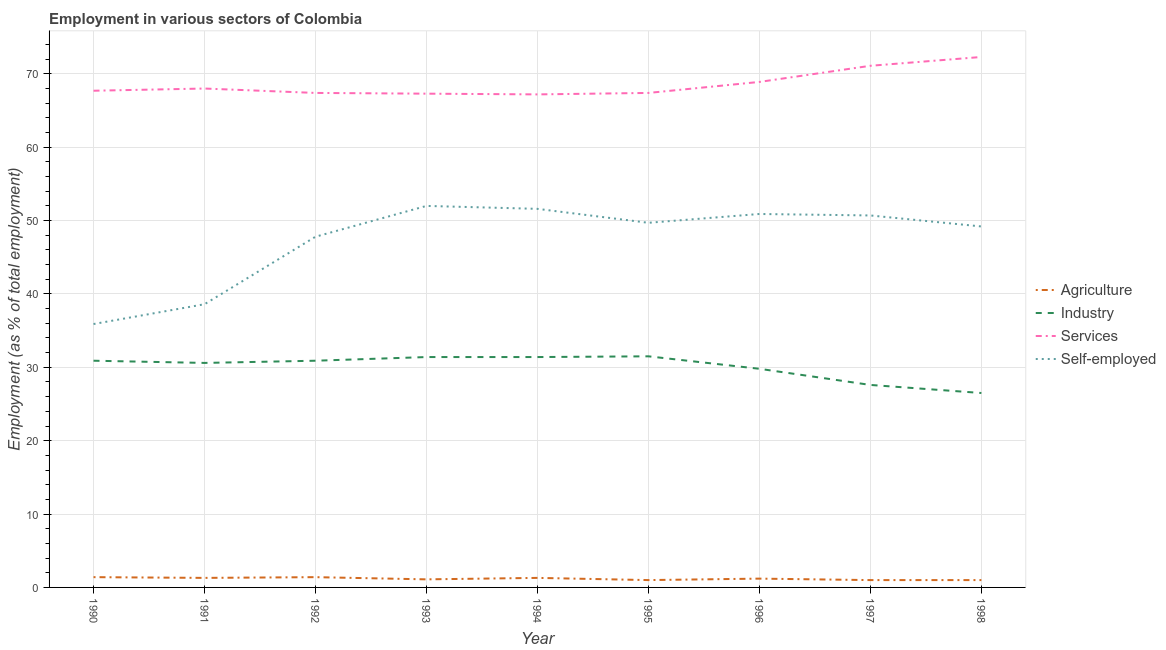How many different coloured lines are there?
Make the answer very short. 4. Does the line corresponding to percentage of workers in services intersect with the line corresponding to percentage of self employed workers?
Give a very brief answer. No. Is the number of lines equal to the number of legend labels?
Your answer should be very brief. Yes. What is the percentage of workers in industry in 1990?
Offer a very short reply. 30.9. Across all years, what is the maximum percentage of self employed workers?
Keep it short and to the point. 52. Across all years, what is the minimum percentage of workers in services?
Your response must be concise. 67.2. In which year was the percentage of workers in services maximum?
Your answer should be very brief. 1998. What is the total percentage of self employed workers in the graph?
Make the answer very short. 426.4. What is the difference between the percentage of workers in industry in 1992 and that in 1998?
Your response must be concise. 4.4. What is the difference between the percentage of workers in services in 1993 and the percentage of self employed workers in 1996?
Provide a short and direct response. 16.4. What is the average percentage of self employed workers per year?
Ensure brevity in your answer.  47.38. In the year 1993, what is the difference between the percentage of workers in services and percentage of workers in industry?
Your answer should be compact. 35.9. What is the ratio of the percentage of workers in agriculture in 1990 to that in 1995?
Your answer should be compact. 1.4. Is the difference between the percentage of workers in agriculture in 1990 and 1997 greater than the difference between the percentage of self employed workers in 1990 and 1997?
Provide a short and direct response. Yes. What is the difference between the highest and the second highest percentage of workers in services?
Your answer should be very brief. 1.2. What is the difference between the highest and the lowest percentage of workers in services?
Provide a succinct answer. 5.1. Is the percentage of self employed workers strictly greater than the percentage of workers in agriculture over the years?
Give a very brief answer. Yes. Is the percentage of workers in services strictly less than the percentage of self employed workers over the years?
Offer a very short reply. No. How many lines are there?
Your answer should be compact. 4. What is the difference between two consecutive major ticks on the Y-axis?
Provide a short and direct response. 10. Are the values on the major ticks of Y-axis written in scientific E-notation?
Your answer should be very brief. No. How are the legend labels stacked?
Provide a succinct answer. Vertical. What is the title of the graph?
Your answer should be compact. Employment in various sectors of Colombia. What is the label or title of the Y-axis?
Give a very brief answer. Employment (as % of total employment). What is the Employment (as % of total employment) in Agriculture in 1990?
Keep it short and to the point. 1.4. What is the Employment (as % of total employment) in Industry in 1990?
Provide a succinct answer. 30.9. What is the Employment (as % of total employment) in Services in 1990?
Make the answer very short. 67.7. What is the Employment (as % of total employment) in Self-employed in 1990?
Your answer should be very brief. 35.9. What is the Employment (as % of total employment) in Agriculture in 1991?
Your answer should be very brief. 1.3. What is the Employment (as % of total employment) in Industry in 1991?
Provide a short and direct response. 30.6. What is the Employment (as % of total employment) of Self-employed in 1991?
Your answer should be compact. 38.6. What is the Employment (as % of total employment) in Agriculture in 1992?
Give a very brief answer. 1.4. What is the Employment (as % of total employment) of Industry in 1992?
Provide a short and direct response. 30.9. What is the Employment (as % of total employment) of Services in 1992?
Offer a terse response. 67.4. What is the Employment (as % of total employment) in Self-employed in 1992?
Provide a succinct answer. 47.8. What is the Employment (as % of total employment) in Agriculture in 1993?
Keep it short and to the point. 1.1. What is the Employment (as % of total employment) in Industry in 1993?
Your response must be concise. 31.4. What is the Employment (as % of total employment) in Services in 1993?
Your answer should be compact. 67.3. What is the Employment (as % of total employment) of Agriculture in 1994?
Make the answer very short. 1.3. What is the Employment (as % of total employment) of Industry in 1994?
Give a very brief answer. 31.4. What is the Employment (as % of total employment) of Services in 1994?
Give a very brief answer. 67.2. What is the Employment (as % of total employment) in Self-employed in 1994?
Your answer should be very brief. 51.6. What is the Employment (as % of total employment) in Industry in 1995?
Your answer should be very brief. 31.5. What is the Employment (as % of total employment) of Services in 1995?
Offer a very short reply. 67.4. What is the Employment (as % of total employment) in Self-employed in 1995?
Your response must be concise. 49.7. What is the Employment (as % of total employment) of Agriculture in 1996?
Your answer should be compact. 1.2. What is the Employment (as % of total employment) in Industry in 1996?
Give a very brief answer. 29.8. What is the Employment (as % of total employment) of Services in 1996?
Ensure brevity in your answer.  68.9. What is the Employment (as % of total employment) in Self-employed in 1996?
Your answer should be compact. 50.9. What is the Employment (as % of total employment) of Industry in 1997?
Provide a succinct answer. 27.6. What is the Employment (as % of total employment) in Services in 1997?
Offer a terse response. 71.1. What is the Employment (as % of total employment) of Self-employed in 1997?
Your response must be concise. 50.7. What is the Employment (as % of total employment) in Industry in 1998?
Keep it short and to the point. 26.5. What is the Employment (as % of total employment) of Services in 1998?
Make the answer very short. 72.3. What is the Employment (as % of total employment) in Self-employed in 1998?
Offer a very short reply. 49.2. Across all years, what is the maximum Employment (as % of total employment) of Agriculture?
Make the answer very short. 1.4. Across all years, what is the maximum Employment (as % of total employment) in Industry?
Your answer should be compact. 31.5. Across all years, what is the maximum Employment (as % of total employment) of Services?
Ensure brevity in your answer.  72.3. Across all years, what is the maximum Employment (as % of total employment) in Self-employed?
Offer a very short reply. 52. Across all years, what is the minimum Employment (as % of total employment) of Agriculture?
Keep it short and to the point. 1. Across all years, what is the minimum Employment (as % of total employment) of Services?
Your answer should be very brief. 67.2. Across all years, what is the minimum Employment (as % of total employment) in Self-employed?
Your answer should be very brief. 35.9. What is the total Employment (as % of total employment) of Agriculture in the graph?
Keep it short and to the point. 10.7. What is the total Employment (as % of total employment) of Industry in the graph?
Your response must be concise. 270.6. What is the total Employment (as % of total employment) of Services in the graph?
Your answer should be compact. 617.3. What is the total Employment (as % of total employment) of Self-employed in the graph?
Make the answer very short. 426.4. What is the difference between the Employment (as % of total employment) of Agriculture in 1990 and that in 1991?
Keep it short and to the point. 0.1. What is the difference between the Employment (as % of total employment) of Services in 1990 and that in 1991?
Give a very brief answer. -0.3. What is the difference between the Employment (as % of total employment) in Services in 1990 and that in 1992?
Your answer should be very brief. 0.3. What is the difference between the Employment (as % of total employment) in Self-employed in 1990 and that in 1993?
Keep it short and to the point. -16.1. What is the difference between the Employment (as % of total employment) in Agriculture in 1990 and that in 1994?
Give a very brief answer. 0.1. What is the difference between the Employment (as % of total employment) in Industry in 1990 and that in 1994?
Provide a short and direct response. -0.5. What is the difference between the Employment (as % of total employment) of Services in 1990 and that in 1994?
Offer a very short reply. 0.5. What is the difference between the Employment (as % of total employment) of Self-employed in 1990 and that in 1994?
Keep it short and to the point. -15.7. What is the difference between the Employment (as % of total employment) of Agriculture in 1990 and that in 1995?
Offer a very short reply. 0.4. What is the difference between the Employment (as % of total employment) in Self-employed in 1990 and that in 1995?
Your answer should be compact. -13.8. What is the difference between the Employment (as % of total employment) in Services in 1990 and that in 1996?
Provide a succinct answer. -1.2. What is the difference between the Employment (as % of total employment) of Agriculture in 1990 and that in 1997?
Offer a terse response. 0.4. What is the difference between the Employment (as % of total employment) of Industry in 1990 and that in 1997?
Your answer should be compact. 3.3. What is the difference between the Employment (as % of total employment) of Self-employed in 1990 and that in 1997?
Your response must be concise. -14.8. What is the difference between the Employment (as % of total employment) of Agriculture in 1990 and that in 1998?
Your answer should be very brief. 0.4. What is the difference between the Employment (as % of total employment) in Industry in 1990 and that in 1998?
Keep it short and to the point. 4.4. What is the difference between the Employment (as % of total employment) in Services in 1990 and that in 1998?
Your answer should be very brief. -4.6. What is the difference between the Employment (as % of total employment) of Self-employed in 1991 and that in 1992?
Keep it short and to the point. -9.2. What is the difference between the Employment (as % of total employment) of Agriculture in 1991 and that in 1993?
Offer a terse response. 0.2. What is the difference between the Employment (as % of total employment) in Industry in 1991 and that in 1993?
Your answer should be very brief. -0.8. What is the difference between the Employment (as % of total employment) of Services in 1991 and that in 1993?
Provide a short and direct response. 0.7. What is the difference between the Employment (as % of total employment) in Self-employed in 1991 and that in 1993?
Your response must be concise. -13.4. What is the difference between the Employment (as % of total employment) in Industry in 1991 and that in 1994?
Keep it short and to the point. -0.8. What is the difference between the Employment (as % of total employment) in Services in 1991 and that in 1994?
Provide a short and direct response. 0.8. What is the difference between the Employment (as % of total employment) of Self-employed in 1991 and that in 1994?
Your answer should be compact. -13. What is the difference between the Employment (as % of total employment) of Agriculture in 1991 and that in 1995?
Provide a succinct answer. 0.3. What is the difference between the Employment (as % of total employment) of Services in 1991 and that in 1996?
Your answer should be compact. -0.9. What is the difference between the Employment (as % of total employment) in Industry in 1991 and that in 1997?
Keep it short and to the point. 3. What is the difference between the Employment (as % of total employment) of Services in 1991 and that in 1997?
Give a very brief answer. -3.1. What is the difference between the Employment (as % of total employment) in Agriculture in 1991 and that in 1998?
Ensure brevity in your answer.  0.3. What is the difference between the Employment (as % of total employment) in Agriculture in 1992 and that in 1993?
Provide a succinct answer. 0.3. What is the difference between the Employment (as % of total employment) of Industry in 1992 and that in 1993?
Offer a terse response. -0.5. What is the difference between the Employment (as % of total employment) of Self-employed in 1992 and that in 1993?
Make the answer very short. -4.2. What is the difference between the Employment (as % of total employment) in Industry in 1992 and that in 1994?
Provide a short and direct response. -0.5. What is the difference between the Employment (as % of total employment) in Services in 1992 and that in 1994?
Keep it short and to the point. 0.2. What is the difference between the Employment (as % of total employment) of Self-employed in 1992 and that in 1994?
Provide a succinct answer. -3.8. What is the difference between the Employment (as % of total employment) of Agriculture in 1992 and that in 1995?
Your answer should be very brief. 0.4. What is the difference between the Employment (as % of total employment) of Services in 1992 and that in 1995?
Keep it short and to the point. 0. What is the difference between the Employment (as % of total employment) of Agriculture in 1992 and that in 1996?
Keep it short and to the point. 0.2. What is the difference between the Employment (as % of total employment) of Industry in 1992 and that in 1997?
Give a very brief answer. 3.3. What is the difference between the Employment (as % of total employment) of Self-employed in 1992 and that in 1997?
Provide a succinct answer. -2.9. What is the difference between the Employment (as % of total employment) of Industry in 1992 and that in 1998?
Your answer should be compact. 4.4. What is the difference between the Employment (as % of total employment) in Industry in 1993 and that in 1994?
Your answer should be compact. 0. What is the difference between the Employment (as % of total employment) in Services in 1993 and that in 1994?
Provide a short and direct response. 0.1. What is the difference between the Employment (as % of total employment) of Self-employed in 1993 and that in 1994?
Offer a terse response. 0.4. What is the difference between the Employment (as % of total employment) of Agriculture in 1993 and that in 1995?
Give a very brief answer. 0.1. What is the difference between the Employment (as % of total employment) in Services in 1993 and that in 1995?
Your answer should be very brief. -0.1. What is the difference between the Employment (as % of total employment) in Self-employed in 1993 and that in 1995?
Ensure brevity in your answer.  2.3. What is the difference between the Employment (as % of total employment) in Industry in 1993 and that in 1997?
Your answer should be compact. 3.8. What is the difference between the Employment (as % of total employment) of Self-employed in 1993 and that in 1997?
Provide a short and direct response. 1.3. What is the difference between the Employment (as % of total employment) of Agriculture in 1993 and that in 1998?
Your answer should be very brief. 0.1. What is the difference between the Employment (as % of total employment) in Services in 1993 and that in 1998?
Provide a succinct answer. -5. What is the difference between the Employment (as % of total employment) in Industry in 1994 and that in 1995?
Provide a short and direct response. -0.1. What is the difference between the Employment (as % of total employment) of Self-employed in 1994 and that in 1995?
Your response must be concise. 1.9. What is the difference between the Employment (as % of total employment) of Services in 1994 and that in 1996?
Your response must be concise. -1.7. What is the difference between the Employment (as % of total employment) of Self-employed in 1994 and that in 1996?
Your response must be concise. 0.7. What is the difference between the Employment (as % of total employment) of Services in 1994 and that in 1997?
Provide a short and direct response. -3.9. What is the difference between the Employment (as % of total employment) of Industry in 1994 and that in 1998?
Your answer should be compact. 4.9. What is the difference between the Employment (as % of total employment) in Self-employed in 1994 and that in 1998?
Provide a succinct answer. 2.4. What is the difference between the Employment (as % of total employment) in Agriculture in 1995 and that in 1996?
Your response must be concise. -0.2. What is the difference between the Employment (as % of total employment) in Industry in 1995 and that in 1996?
Your answer should be compact. 1.7. What is the difference between the Employment (as % of total employment) in Self-employed in 1995 and that in 1996?
Give a very brief answer. -1.2. What is the difference between the Employment (as % of total employment) of Industry in 1995 and that in 1997?
Offer a very short reply. 3.9. What is the difference between the Employment (as % of total employment) in Services in 1995 and that in 1997?
Provide a succinct answer. -3.7. What is the difference between the Employment (as % of total employment) in Agriculture in 1995 and that in 1998?
Provide a short and direct response. 0. What is the difference between the Employment (as % of total employment) in Industry in 1995 and that in 1998?
Make the answer very short. 5. What is the difference between the Employment (as % of total employment) of Agriculture in 1996 and that in 1997?
Make the answer very short. 0.2. What is the difference between the Employment (as % of total employment) in Industry in 1996 and that in 1997?
Ensure brevity in your answer.  2.2. What is the difference between the Employment (as % of total employment) in Self-employed in 1996 and that in 1997?
Make the answer very short. 0.2. What is the difference between the Employment (as % of total employment) in Agriculture in 1996 and that in 1998?
Your answer should be very brief. 0.2. What is the difference between the Employment (as % of total employment) of Services in 1996 and that in 1998?
Your answer should be very brief. -3.4. What is the difference between the Employment (as % of total employment) in Agriculture in 1997 and that in 1998?
Offer a very short reply. 0. What is the difference between the Employment (as % of total employment) of Self-employed in 1997 and that in 1998?
Your answer should be compact. 1.5. What is the difference between the Employment (as % of total employment) in Agriculture in 1990 and the Employment (as % of total employment) in Industry in 1991?
Provide a succinct answer. -29.2. What is the difference between the Employment (as % of total employment) in Agriculture in 1990 and the Employment (as % of total employment) in Services in 1991?
Your response must be concise. -66.6. What is the difference between the Employment (as % of total employment) in Agriculture in 1990 and the Employment (as % of total employment) in Self-employed in 1991?
Ensure brevity in your answer.  -37.2. What is the difference between the Employment (as % of total employment) in Industry in 1990 and the Employment (as % of total employment) in Services in 1991?
Make the answer very short. -37.1. What is the difference between the Employment (as % of total employment) of Industry in 1990 and the Employment (as % of total employment) of Self-employed in 1991?
Your answer should be very brief. -7.7. What is the difference between the Employment (as % of total employment) of Services in 1990 and the Employment (as % of total employment) of Self-employed in 1991?
Your answer should be compact. 29.1. What is the difference between the Employment (as % of total employment) of Agriculture in 1990 and the Employment (as % of total employment) of Industry in 1992?
Provide a succinct answer. -29.5. What is the difference between the Employment (as % of total employment) in Agriculture in 1990 and the Employment (as % of total employment) in Services in 1992?
Your response must be concise. -66. What is the difference between the Employment (as % of total employment) of Agriculture in 1990 and the Employment (as % of total employment) of Self-employed in 1992?
Your answer should be very brief. -46.4. What is the difference between the Employment (as % of total employment) of Industry in 1990 and the Employment (as % of total employment) of Services in 1992?
Give a very brief answer. -36.5. What is the difference between the Employment (as % of total employment) of Industry in 1990 and the Employment (as % of total employment) of Self-employed in 1992?
Offer a terse response. -16.9. What is the difference between the Employment (as % of total employment) of Agriculture in 1990 and the Employment (as % of total employment) of Industry in 1993?
Provide a succinct answer. -30. What is the difference between the Employment (as % of total employment) in Agriculture in 1990 and the Employment (as % of total employment) in Services in 1993?
Offer a very short reply. -65.9. What is the difference between the Employment (as % of total employment) of Agriculture in 1990 and the Employment (as % of total employment) of Self-employed in 1993?
Give a very brief answer. -50.6. What is the difference between the Employment (as % of total employment) of Industry in 1990 and the Employment (as % of total employment) of Services in 1993?
Offer a very short reply. -36.4. What is the difference between the Employment (as % of total employment) of Industry in 1990 and the Employment (as % of total employment) of Self-employed in 1993?
Ensure brevity in your answer.  -21.1. What is the difference between the Employment (as % of total employment) in Services in 1990 and the Employment (as % of total employment) in Self-employed in 1993?
Your response must be concise. 15.7. What is the difference between the Employment (as % of total employment) in Agriculture in 1990 and the Employment (as % of total employment) in Industry in 1994?
Provide a short and direct response. -30. What is the difference between the Employment (as % of total employment) of Agriculture in 1990 and the Employment (as % of total employment) of Services in 1994?
Provide a short and direct response. -65.8. What is the difference between the Employment (as % of total employment) in Agriculture in 1990 and the Employment (as % of total employment) in Self-employed in 1994?
Your answer should be very brief. -50.2. What is the difference between the Employment (as % of total employment) of Industry in 1990 and the Employment (as % of total employment) of Services in 1994?
Your answer should be compact. -36.3. What is the difference between the Employment (as % of total employment) in Industry in 1990 and the Employment (as % of total employment) in Self-employed in 1994?
Keep it short and to the point. -20.7. What is the difference between the Employment (as % of total employment) of Services in 1990 and the Employment (as % of total employment) of Self-employed in 1994?
Provide a succinct answer. 16.1. What is the difference between the Employment (as % of total employment) in Agriculture in 1990 and the Employment (as % of total employment) in Industry in 1995?
Keep it short and to the point. -30.1. What is the difference between the Employment (as % of total employment) in Agriculture in 1990 and the Employment (as % of total employment) in Services in 1995?
Ensure brevity in your answer.  -66. What is the difference between the Employment (as % of total employment) in Agriculture in 1990 and the Employment (as % of total employment) in Self-employed in 1995?
Offer a terse response. -48.3. What is the difference between the Employment (as % of total employment) in Industry in 1990 and the Employment (as % of total employment) in Services in 1995?
Keep it short and to the point. -36.5. What is the difference between the Employment (as % of total employment) of Industry in 1990 and the Employment (as % of total employment) of Self-employed in 1995?
Keep it short and to the point. -18.8. What is the difference between the Employment (as % of total employment) in Agriculture in 1990 and the Employment (as % of total employment) in Industry in 1996?
Offer a terse response. -28.4. What is the difference between the Employment (as % of total employment) of Agriculture in 1990 and the Employment (as % of total employment) of Services in 1996?
Ensure brevity in your answer.  -67.5. What is the difference between the Employment (as % of total employment) of Agriculture in 1990 and the Employment (as % of total employment) of Self-employed in 1996?
Your answer should be compact. -49.5. What is the difference between the Employment (as % of total employment) in Industry in 1990 and the Employment (as % of total employment) in Services in 1996?
Keep it short and to the point. -38. What is the difference between the Employment (as % of total employment) of Agriculture in 1990 and the Employment (as % of total employment) of Industry in 1997?
Make the answer very short. -26.2. What is the difference between the Employment (as % of total employment) in Agriculture in 1990 and the Employment (as % of total employment) in Services in 1997?
Keep it short and to the point. -69.7. What is the difference between the Employment (as % of total employment) in Agriculture in 1990 and the Employment (as % of total employment) in Self-employed in 1997?
Give a very brief answer. -49.3. What is the difference between the Employment (as % of total employment) in Industry in 1990 and the Employment (as % of total employment) in Services in 1997?
Your answer should be very brief. -40.2. What is the difference between the Employment (as % of total employment) in Industry in 1990 and the Employment (as % of total employment) in Self-employed in 1997?
Your answer should be very brief. -19.8. What is the difference between the Employment (as % of total employment) in Services in 1990 and the Employment (as % of total employment) in Self-employed in 1997?
Your answer should be compact. 17. What is the difference between the Employment (as % of total employment) of Agriculture in 1990 and the Employment (as % of total employment) of Industry in 1998?
Give a very brief answer. -25.1. What is the difference between the Employment (as % of total employment) in Agriculture in 1990 and the Employment (as % of total employment) in Services in 1998?
Provide a succinct answer. -70.9. What is the difference between the Employment (as % of total employment) of Agriculture in 1990 and the Employment (as % of total employment) of Self-employed in 1998?
Offer a terse response. -47.8. What is the difference between the Employment (as % of total employment) of Industry in 1990 and the Employment (as % of total employment) of Services in 1998?
Provide a short and direct response. -41.4. What is the difference between the Employment (as % of total employment) in Industry in 1990 and the Employment (as % of total employment) in Self-employed in 1998?
Give a very brief answer. -18.3. What is the difference between the Employment (as % of total employment) of Agriculture in 1991 and the Employment (as % of total employment) of Industry in 1992?
Your answer should be very brief. -29.6. What is the difference between the Employment (as % of total employment) of Agriculture in 1991 and the Employment (as % of total employment) of Services in 1992?
Offer a terse response. -66.1. What is the difference between the Employment (as % of total employment) in Agriculture in 1991 and the Employment (as % of total employment) in Self-employed in 1992?
Offer a very short reply. -46.5. What is the difference between the Employment (as % of total employment) in Industry in 1991 and the Employment (as % of total employment) in Services in 1992?
Offer a terse response. -36.8. What is the difference between the Employment (as % of total employment) of Industry in 1991 and the Employment (as % of total employment) of Self-employed in 1992?
Keep it short and to the point. -17.2. What is the difference between the Employment (as % of total employment) of Services in 1991 and the Employment (as % of total employment) of Self-employed in 1992?
Your answer should be very brief. 20.2. What is the difference between the Employment (as % of total employment) in Agriculture in 1991 and the Employment (as % of total employment) in Industry in 1993?
Offer a terse response. -30.1. What is the difference between the Employment (as % of total employment) of Agriculture in 1991 and the Employment (as % of total employment) of Services in 1993?
Make the answer very short. -66. What is the difference between the Employment (as % of total employment) of Agriculture in 1991 and the Employment (as % of total employment) of Self-employed in 1993?
Keep it short and to the point. -50.7. What is the difference between the Employment (as % of total employment) in Industry in 1991 and the Employment (as % of total employment) in Services in 1993?
Ensure brevity in your answer.  -36.7. What is the difference between the Employment (as % of total employment) of Industry in 1991 and the Employment (as % of total employment) of Self-employed in 1993?
Your answer should be compact. -21.4. What is the difference between the Employment (as % of total employment) of Agriculture in 1991 and the Employment (as % of total employment) of Industry in 1994?
Provide a short and direct response. -30.1. What is the difference between the Employment (as % of total employment) of Agriculture in 1991 and the Employment (as % of total employment) of Services in 1994?
Offer a very short reply. -65.9. What is the difference between the Employment (as % of total employment) of Agriculture in 1991 and the Employment (as % of total employment) of Self-employed in 1994?
Your answer should be very brief. -50.3. What is the difference between the Employment (as % of total employment) of Industry in 1991 and the Employment (as % of total employment) of Services in 1994?
Keep it short and to the point. -36.6. What is the difference between the Employment (as % of total employment) of Industry in 1991 and the Employment (as % of total employment) of Self-employed in 1994?
Offer a terse response. -21. What is the difference between the Employment (as % of total employment) in Agriculture in 1991 and the Employment (as % of total employment) in Industry in 1995?
Offer a terse response. -30.2. What is the difference between the Employment (as % of total employment) of Agriculture in 1991 and the Employment (as % of total employment) of Services in 1995?
Give a very brief answer. -66.1. What is the difference between the Employment (as % of total employment) of Agriculture in 1991 and the Employment (as % of total employment) of Self-employed in 1995?
Your response must be concise. -48.4. What is the difference between the Employment (as % of total employment) in Industry in 1991 and the Employment (as % of total employment) in Services in 1995?
Your response must be concise. -36.8. What is the difference between the Employment (as % of total employment) of Industry in 1991 and the Employment (as % of total employment) of Self-employed in 1995?
Offer a terse response. -19.1. What is the difference between the Employment (as % of total employment) of Agriculture in 1991 and the Employment (as % of total employment) of Industry in 1996?
Your answer should be compact. -28.5. What is the difference between the Employment (as % of total employment) of Agriculture in 1991 and the Employment (as % of total employment) of Services in 1996?
Your answer should be very brief. -67.6. What is the difference between the Employment (as % of total employment) in Agriculture in 1991 and the Employment (as % of total employment) in Self-employed in 1996?
Give a very brief answer. -49.6. What is the difference between the Employment (as % of total employment) in Industry in 1991 and the Employment (as % of total employment) in Services in 1996?
Provide a succinct answer. -38.3. What is the difference between the Employment (as % of total employment) of Industry in 1991 and the Employment (as % of total employment) of Self-employed in 1996?
Offer a terse response. -20.3. What is the difference between the Employment (as % of total employment) in Agriculture in 1991 and the Employment (as % of total employment) in Industry in 1997?
Offer a very short reply. -26.3. What is the difference between the Employment (as % of total employment) in Agriculture in 1991 and the Employment (as % of total employment) in Services in 1997?
Give a very brief answer. -69.8. What is the difference between the Employment (as % of total employment) in Agriculture in 1991 and the Employment (as % of total employment) in Self-employed in 1997?
Keep it short and to the point. -49.4. What is the difference between the Employment (as % of total employment) in Industry in 1991 and the Employment (as % of total employment) in Services in 1997?
Make the answer very short. -40.5. What is the difference between the Employment (as % of total employment) in Industry in 1991 and the Employment (as % of total employment) in Self-employed in 1997?
Your answer should be compact. -20.1. What is the difference between the Employment (as % of total employment) of Services in 1991 and the Employment (as % of total employment) of Self-employed in 1997?
Your answer should be very brief. 17.3. What is the difference between the Employment (as % of total employment) of Agriculture in 1991 and the Employment (as % of total employment) of Industry in 1998?
Keep it short and to the point. -25.2. What is the difference between the Employment (as % of total employment) in Agriculture in 1991 and the Employment (as % of total employment) in Services in 1998?
Your response must be concise. -71. What is the difference between the Employment (as % of total employment) of Agriculture in 1991 and the Employment (as % of total employment) of Self-employed in 1998?
Keep it short and to the point. -47.9. What is the difference between the Employment (as % of total employment) of Industry in 1991 and the Employment (as % of total employment) of Services in 1998?
Provide a short and direct response. -41.7. What is the difference between the Employment (as % of total employment) in Industry in 1991 and the Employment (as % of total employment) in Self-employed in 1998?
Give a very brief answer. -18.6. What is the difference between the Employment (as % of total employment) in Services in 1991 and the Employment (as % of total employment) in Self-employed in 1998?
Your answer should be compact. 18.8. What is the difference between the Employment (as % of total employment) of Agriculture in 1992 and the Employment (as % of total employment) of Services in 1993?
Make the answer very short. -65.9. What is the difference between the Employment (as % of total employment) in Agriculture in 1992 and the Employment (as % of total employment) in Self-employed in 1993?
Keep it short and to the point. -50.6. What is the difference between the Employment (as % of total employment) of Industry in 1992 and the Employment (as % of total employment) of Services in 1993?
Your response must be concise. -36.4. What is the difference between the Employment (as % of total employment) in Industry in 1992 and the Employment (as % of total employment) in Self-employed in 1993?
Keep it short and to the point. -21.1. What is the difference between the Employment (as % of total employment) in Agriculture in 1992 and the Employment (as % of total employment) in Industry in 1994?
Your answer should be very brief. -30. What is the difference between the Employment (as % of total employment) of Agriculture in 1992 and the Employment (as % of total employment) of Services in 1994?
Provide a short and direct response. -65.8. What is the difference between the Employment (as % of total employment) in Agriculture in 1992 and the Employment (as % of total employment) in Self-employed in 1994?
Offer a very short reply. -50.2. What is the difference between the Employment (as % of total employment) in Industry in 1992 and the Employment (as % of total employment) in Services in 1994?
Your answer should be compact. -36.3. What is the difference between the Employment (as % of total employment) of Industry in 1992 and the Employment (as % of total employment) of Self-employed in 1994?
Provide a succinct answer. -20.7. What is the difference between the Employment (as % of total employment) in Services in 1992 and the Employment (as % of total employment) in Self-employed in 1994?
Give a very brief answer. 15.8. What is the difference between the Employment (as % of total employment) in Agriculture in 1992 and the Employment (as % of total employment) in Industry in 1995?
Offer a very short reply. -30.1. What is the difference between the Employment (as % of total employment) of Agriculture in 1992 and the Employment (as % of total employment) of Services in 1995?
Provide a succinct answer. -66. What is the difference between the Employment (as % of total employment) of Agriculture in 1992 and the Employment (as % of total employment) of Self-employed in 1995?
Give a very brief answer. -48.3. What is the difference between the Employment (as % of total employment) in Industry in 1992 and the Employment (as % of total employment) in Services in 1995?
Ensure brevity in your answer.  -36.5. What is the difference between the Employment (as % of total employment) of Industry in 1992 and the Employment (as % of total employment) of Self-employed in 1995?
Make the answer very short. -18.8. What is the difference between the Employment (as % of total employment) of Services in 1992 and the Employment (as % of total employment) of Self-employed in 1995?
Provide a short and direct response. 17.7. What is the difference between the Employment (as % of total employment) of Agriculture in 1992 and the Employment (as % of total employment) of Industry in 1996?
Your answer should be compact. -28.4. What is the difference between the Employment (as % of total employment) in Agriculture in 1992 and the Employment (as % of total employment) in Services in 1996?
Offer a very short reply. -67.5. What is the difference between the Employment (as % of total employment) of Agriculture in 1992 and the Employment (as % of total employment) of Self-employed in 1996?
Give a very brief answer. -49.5. What is the difference between the Employment (as % of total employment) of Industry in 1992 and the Employment (as % of total employment) of Services in 1996?
Give a very brief answer. -38. What is the difference between the Employment (as % of total employment) in Industry in 1992 and the Employment (as % of total employment) in Self-employed in 1996?
Give a very brief answer. -20. What is the difference between the Employment (as % of total employment) of Agriculture in 1992 and the Employment (as % of total employment) of Industry in 1997?
Make the answer very short. -26.2. What is the difference between the Employment (as % of total employment) of Agriculture in 1992 and the Employment (as % of total employment) of Services in 1997?
Provide a succinct answer. -69.7. What is the difference between the Employment (as % of total employment) of Agriculture in 1992 and the Employment (as % of total employment) of Self-employed in 1997?
Your answer should be very brief. -49.3. What is the difference between the Employment (as % of total employment) of Industry in 1992 and the Employment (as % of total employment) of Services in 1997?
Keep it short and to the point. -40.2. What is the difference between the Employment (as % of total employment) of Industry in 1992 and the Employment (as % of total employment) of Self-employed in 1997?
Offer a terse response. -19.8. What is the difference between the Employment (as % of total employment) in Services in 1992 and the Employment (as % of total employment) in Self-employed in 1997?
Provide a succinct answer. 16.7. What is the difference between the Employment (as % of total employment) in Agriculture in 1992 and the Employment (as % of total employment) in Industry in 1998?
Your answer should be very brief. -25.1. What is the difference between the Employment (as % of total employment) in Agriculture in 1992 and the Employment (as % of total employment) in Services in 1998?
Provide a short and direct response. -70.9. What is the difference between the Employment (as % of total employment) in Agriculture in 1992 and the Employment (as % of total employment) in Self-employed in 1998?
Provide a short and direct response. -47.8. What is the difference between the Employment (as % of total employment) of Industry in 1992 and the Employment (as % of total employment) of Services in 1998?
Offer a terse response. -41.4. What is the difference between the Employment (as % of total employment) in Industry in 1992 and the Employment (as % of total employment) in Self-employed in 1998?
Your response must be concise. -18.3. What is the difference between the Employment (as % of total employment) of Agriculture in 1993 and the Employment (as % of total employment) of Industry in 1994?
Keep it short and to the point. -30.3. What is the difference between the Employment (as % of total employment) in Agriculture in 1993 and the Employment (as % of total employment) in Services in 1994?
Your answer should be compact. -66.1. What is the difference between the Employment (as % of total employment) of Agriculture in 1993 and the Employment (as % of total employment) of Self-employed in 1994?
Your response must be concise. -50.5. What is the difference between the Employment (as % of total employment) in Industry in 1993 and the Employment (as % of total employment) in Services in 1994?
Provide a succinct answer. -35.8. What is the difference between the Employment (as % of total employment) in Industry in 1993 and the Employment (as % of total employment) in Self-employed in 1994?
Your response must be concise. -20.2. What is the difference between the Employment (as % of total employment) of Services in 1993 and the Employment (as % of total employment) of Self-employed in 1994?
Keep it short and to the point. 15.7. What is the difference between the Employment (as % of total employment) in Agriculture in 1993 and the Employment (as % of total employment) in Industry in 1995?
Provide a succinct answer. -30.4. What is the difference between the Employment (as % of total employment) of Agriculture in 1993 and the Employment (as % of total employment) of Services in 1995?
Your answer should be compact. -66.3. What is the difference between the Employment (as % of total employment) in Agriculture in 1993 and the Employment (as % of total employment) in Self-employed in 1995?
Make the answer very short. -48.6. What is the difference between the Employment (as % of total employment) in Industry in 1993 and the Employment (as % of total employment) in Services in 1995?
Your answer should be very brief. -36. What is the difference between the Employment (as % of total employment) in Industry in 1993 and the Employment (as % of total employment) in Self-employed in 1995?
Offer a very short reply. -18.3. What is the difference between the Employment (as % of total employment) of Services in 1993 and the Employment (as % of total employment) of Self-employed in 1995?
Keep it short and to the point. 17.6. What is the difference between the Employment (as % of total employment) in Agriculture in 1993 and the Employment (as % of total employment) in Industry in 1996?
Offer a terse response. -28.7. What is the difference between the Employment (as % of total employment) in Agriculture in 1993 and the Employment (as % of total employment) in Services in 1996?
Offer a terse response. -67.8. What is the difference between the Employment (as % of total employment) of Agriculture in 1993 and the Employment (as % of total employment) of Self-employed in 1996?
Your answer should be compact. -49.8. What is the difference between the Employment (as % of total employment) in Industry in 1993 and the Employment (as % of total employment) in Services in 1996?
Your answer should be compact. -37.5. What is the difference between the Employment (as % of total employment) in Industry in 1993 and the Employment (as % of total employment) in Self-employed in 1996?
Your answer should be compact. -19.5. What is the difference between the Employment (as % of total employment) of Agriculture in 1993 and the Employment (as % of total employment) of Industry in 1997?
Your answer should be compact. -26.5. What is the difference between the Employment (as % of total employment) in Agriculture in 1993 and the Employment (as % of total employment) in Services in 1997?
Make the answer very short. -70. What is the difference between the Employment (as % of total employment) of Agriculture in 1993 and the Employment (as % of total employment) of Self-employed in 1997?
Keep it short and to the point. -49.6. What is the difference between the Employment (as % of total employment) in Industry in 1993 and the Employment (as % of total employment) in Services in 1997?
Ensure brevity in your answer.  -39.7. What is the difference between the Employment (as % of total employment) of Industry in 1993 and the Employment (as % of total employment) of Self-employed in 1997?
Keep it short and to the point. -19.3. What is the difference between the Employment (as % of total employment) in Services in 1993 and the Employment (as % of total employment) in Self-employed in 1997?
Offer a very short reply. 16.6. What is the difference between the Employment (as % of total employment) in Agriculture in 1993 and the Employment (as % of total employment) in Industry in 1998?
Make the answer very short. -25.4. What is the difference between the Employment (as % of total employment) in Agriculture in 1993 and the Employment (as % of total employment) in Services in 1998?
Offer a very short reply. -71.2. What is the difference between the Employment (as % of total employment) in Agriculture in 1993 and the Employment (as % of total employment) in Self-employed in 1998?
Offer a terse response. -48.1. What is the difference between the Employment (as % of total employment) in Industry in 1993 and the Employment (as % of total employment) in Services in 1998?
Provide a short and direct response. -40.9. What is the difference between the Employment (as % of total employment) in Industry in 1993 and the Employment (as % of total employment) in Self-employed in 1998?
Make the answer very short. -17.8. What is the difference between the Employment (as % of total employment) in Services in 1993 and the Employment (as % of total employment) in Self-employed in 1998?
Ensure brevity in your answer.  18.1. What is the difference between the Employment (as % of total employment) in Agriculture in 1994 and the Employment (as % of total employment) in Industry in 1995?
Keep it short and to the point. -30.2. What is the difference between the Employment (as % of total employment) in Agriculture in 1994 and the Employment (as % of total employment) in Services in 1995?
Offer a terse response. -66.1. What is the difference between the Employment (as % of total employment) in Agriculture in 1994 and the Employment (as % of total employment) in Self-employed in 1995?
Give a very brief answer. -48.4. What is the difference between the Employment (as % of total employment) in Industry in 1994 and the Employment (as % of total employment) in Services in 1995?
Provide a short and direct response. -36. What is the difference between the Employment (as % of total employment) of Industry in 1994 and the Employment (as % of total employment) of Self-employed in 1995?
Your answer should be very brief. -18.3. What is the difference between the Employment (as % of total employment) in Services in 1994 and the Employment (as % of total employment) in Self-employed in 1995?
Ensure brevity in your answer.  17.5. What is the difference between the Employment (as % of total employment) of Agriculture in 1994 and the Employment (as % of total employment) of Industry in 1996?
Your answer should be compact. -28.5. What is the difference between the Employment (as % of total employment) of Agriculture in 1994 and the Employment (as % of total employment) of Services in 1996?
Ensure brevity in your answer.  -67.6. What is the difference between the Employment (as % of total employment) in Agriculture in 1994 and the Employment (as % of total employment) in Self-employed in 1996?
Provide a succinct answer. -49.6. What is the difference between the Employment (as % of total employment) in Industry in 1994 and the Employment (as % of total employment) in Services in 1996?
Ensure brevity in your answer.  -37.5. What is the difference between the Employment (as % of total employment) of Industry in 1994 and the Employment (as % of total employment) of Self-employed in 1996?
Ensure brevity in your answer.  -19.5. What is the difference between the Employment (as % of total employment) of Services in 1994 and the Employment (as % of total employment) of Self-employed in 1996?
Make the answer very short. 16.3. What is the difference between the Employment (as % of total employment) of Agriculture in 1994 and the Employment (as % of total employment) of Industry in 1997?
Offer a very short reply. -26.3. What is the difference between the Employment (as % of total employment) of Agriculture in 1994 and the Employment (as % of total employment) of Services in 1997?
Your answer should be very brief. -69.8. What is the difference between the Employment (as % of total employment) in Agriculture in 1994 and the Employment (as % of total employment) in Self-employed in 1997?
Offer a terse response. -49.4. What is the difference between the Employment (as % of total employment) in Industry in 1994 and the Employment (as % of total employment) in Services in 1997?
Offer a very short reply. -39.7. What is the difference between the Employment (as % of total employment) of Industry in 1994 and the Employment (as % of total employment) of Self-employed in 1997?
Keep it short and to the point. -19.3. What is the difference between the Employment (as % of total employment) of Services in 1994 and the Employment (as % of total employment) of Self-employed in 1997?
Make the answer very short. 16.5. What is the difference between the Employment (as % of total employment) of Agriculture in 1994 and the Employment (as % of total employment) of Industry in 1998?
Ensure brevity in your answer.  -25.2. What is the difference between the Employment (as % of total employment) of Agriculture in 1994 and the Employment (as % of total employment) of Services in 1998?
Your answer should be compact. -71. What is the difference between the Employment (as % of total employment) in Agriculture in 1994 and the Employment (as % of total employment) in Self-employed in 1998?
Your answer should be very brief. -47.9. What is the difference between the Employment (as % of total employment) of Industry in 1994 and the Employment (as % of total employment) of Services in 1998?
Your response must be concise. -40.9. What is the difference between the Employment (as % of total employment) of Industry in 1994 and the Employment (as % of total employment) of Self-employed in 1998?
Your response must be concise. -17.8. What is the difference between the Employment (as % of total employment) of Agriculture in 1995 and the Employment (as % of total employment) of Industry in 1996?
Your answer should be very brief. -28.8. What is the difference between the Employment (as % of total employment) of Agriculture in 1995 and the Employment (as % of total employment) of Services in 1996?
Provide a succinct answer. -67.9. What is the difference between the Employment (as % of total employment) of Agriculture in 1995 and the Employment (as % of total employment) of Self-employed in 1996?
Provide a short and direct response. -49.9. What is the difference between the Employment (as % of total employment) in Industry in 1995 and the Employment (as % of total employment) in Services in 1996?
Offer a terse response. -37.4. What is the difference between the Employment (as % of total employment) in Industry in 1995 and the Employment (as % of total employment) in Self-employed in 1996?
Ensure brevity in your answer.  -19.4. What is the difference between the Employment (as % of total employment) of Agriculture in 1995 and the Employment (as % of total employment) of Industry in 1997?
Your response must be concise. -26.6. What is the difference between the Employment (as % of total employment) in Agriculture in 1995 and the Employment (as % of total employment) in Services in 1997?
Ensure brevity in your answer.  -70.1. What is the difference between the Employment (as % of total employment) of Agriculture in 1995 and the Employment (as % of total employment) of Self-employed in 1997?
Your answer should be compact. -49.7. What is the difference between the Employment (as % of total employment) of Industry in 1995 and the Employment (as % of total employment) of Services in 1997?
Keep it short and to the point. -39.6. What is the difference between the Employment (as % of total employment) of Industry in 1995 and the Employment (as % of total employment) of Self-employed in 1997?
Your answer should be compact. -19.2. What is the difference between the Employment (as % of total employment) of Services in 1995 and the Employment (as % of total employment) of Self-employed in 1997?
Your response must be concise. 16.7. What is the difference between the Employment (as % of total employment) of Agriculture in 1995 and the Employment (as % of total employment) of Industry in 1998?
Keep it short and to the point. -25.5. What is the difference between the Employment (as % of total employment) in Agriculture in 1995 and the Employment (as % of total employment) in Services in 1998?
Make the answer very short. -71.3. What is the difference between the Employment (as % of total employment) of Agriculture in 1995 and the Employment (as % of total employment) of Self-employed in 1998?
Give a very brief answer. -48.2. What is the difference between the Employment (as % of total employment) in Industry in 1995 and the Employment (as % of total employment) in Services in 1998?
Your response must be concise. -40.8. What is the difference between the Employment (as % of total employment) in Industry in 1995 and the Employment (as % of total employment) in Self-employed in 1998?
Offer a terse response. -17.7. What is the difference between the Employment (as % of total employment) of Agriculture in 1996 and the Employment (as % of total employment) of Industry in 1997?
Keep it short and to the point. -26.4. What is the difference between the Employment (as % of total employment) in Agriculture in 1996 and the Employment (as % of total employment) in Services in 1997?
Give a very brief answer. -69.9. What is the difference between the Employment (as % of total employment) in Agriculture in 1996 and the Employment (as % of total employment) in Self-employed in 1997?
Provide a short and direct response. -49.5. What is the difference between the Employment (as % of total employment) of Industry in 1996 and the Employment (as % of total employment) of Services in 1997?
Make the answer very short. -41.3. What is the difference between the Employment (as % of total employment) of Industry in 1996 and the Employment (as % of total employment) of Self-employed in 1997?
Offer a very short reply. -20.9. What is the difference between the Employment (as % of total employment) of Services in 1996 and the Employment (as % of total employment) of Self-employed in 1997?
Ensure brevity in your answer.  18.2. What is the difference between the Employment (as % of total employment) in Agriculture in 1996 and the Employment (as % of total employment) in Industry in 1998?
Make the answer very short. -25.3. What is the difference between the Employment (as % of total employment) in Agriculture in 1996 and the Employment (as % of total employment) in Services in 1998?
Your answer should be compact. -71.1. What is the difference between the Employment (as % of total employment) of Agriculture in 1996 and the Employment (as % of total employment) of Self-employed in 1998?
Make the answer very short. -48. What is the difference between the Employment (as % of total employment) of Industry in 1996 and the Employment (as % of total employment) of Services in 1998?
Provide a succinct answer. -42.5. What is the difference between the Employment (as % of total employment) in Industry in 1996 and the Employment (as % of total employment) in Self-employed in 1998?
Provide a succinct answer. -19.4. What is the difference between the Employment (as % of total employment) in Agriculture in 1997 and the Employment (as % of total employment) in Industry in 1998?
Provide a short and direct response. -25.5. What is the difference between the Employment (as % of total employment) in Agriculture in 1997 and the Employment (as % of total employment) in Services in 1998?
Keep it short and to the point. -71.3. What is the difference between the Employment (as % of total employment) of Agriculture in 1997 and the Employment (as % of total employment) of Self-employed in 1998?
Offer a terse response. -48.2. What is the difference between the Employment (as % of total employment) in Industry in 1997 and the Employment (as % of total employment) in Services in 1998?
Give a very brief answer. -44.7. What is the difference between the Employment (as % of total employment) in Industry in 1997 and the Employment (as % of total employment) in Self-employed in 1998?
Give a very brief answer. -21.6. What is the difference between the Employment (as % of total employment) of Services in 1997 and the Employment (as % of total employment) of Self-employed in 1998?
Keep it short and to the point. 21.9. What is the average Employment (as % of total employment) in Agriculture per year?
Make the answer very short. 1.19. What is the average Employment (as % of total employment) of Industry per year?
Keep it short and to the point. 30.07. What is the average Employment (as % of total employment) of Services per year?
Your answer should be very brief. 68.59. What is the average Employment (as % of total employment) in Self-employed per year?
Your answer should be compact. 47.38. In the year 1990, what is the difference between the Employment (as % of total employment) in Agriculture and Employment (as % of total employment) in Industry?
Give a very brief answer. -29.5. In the year 1990, what is the difference between the Employment (as % of total employment) of Agriculture and Employment (as % of total employment) of Services?
Give a very brief answer. -66.3. In the year 1990, what is the difference between the Employment (as % of total employment) of Agriculture and Employment (as % of total employment) of Self-employed?
Give a very brief answer. -34.5. In the year 1990, what is the difference between the Employment (as % of total employment) in Industry and Employment (as % of total employment) in Services?
Offer a terse response. -36.8. In the year 1990, what is the difference between the Employment (as % of total employment) of Industry and Employment (as % of total employment) of Self-employed?
Your answer should be very brief. -5. In the year 1990, what is the difference between the Employment (as % of total employment) of Services and Employment (as % of total employment) of Self-employed?
Make the answer very short. 31.8. In the year 1991, what is the difference between the Employment (as % of total employment) in Agriculture and Employment (as % of total employment) in Industry?
Offer a very short reply. -29.3. In the year 1991, what is the difference between the Employment (as % of total employment) of Agriculture and Employment (as % of total employment) of Services?
Your response must be concise. -66.7. In the year 1991, what is the difference between the Employment (as % of total employment) in Agriculture and Employment (as % of total employment) in Self-employed?
Your answer should be compact. -37.3. In the year 1991, what is the difference between the Employment (as % of total employment) of Industry and Employment (as % of total employment) of Services?
Offer a terse response. -37.4. In the year 1991, what is the difference between the Employment (as % of total employment) in Services and Employment (as % of total employment) in Self-employed?
Make the answer very short. 29.4. In the year 1992, what is the difference between the Employment (as % of total employment) of Agriculture and Employment (as % of total employment) of Industry?
Your response must be concise. -29.5. In the year 1992, what is the difference between the Employment (as % of total employment) in Agriculture and Employment (as % of total employment) in Services?
Offer a terse response. -66. In the year 1992, what is the difference between the Employment (as % of total employment) in Agriculture and Employment (as % of total employment) in Self-employed?
Provide a short and direct response. -46.4. In the year 1992, what is the difference between the Employment (as % of total employment) in Industry and Employment (as % of total employment) in Services?
Offer a terse response. -36.5. In the year 1992, what is the difference between the Employment (as % of total employment) of Industry and Employment (as % of total employment) of Self-employed?
Your answer should be compact. -16.9. In the year 1992, what is the difference between the Employment (as % of total employment) of Services and Employment (as % of total employment) of Self-employed?
Your answer should be compact. 19.6. In the year 1993, what is the difference between the Employment (as % of total employment) in Agriculture and Employment (as % of total employment) in Industry?
Your answer should be very brief. -30.3. In the year 1993, what is the difference between the Employment (as % of total employment) of Agriculture and Employment (as % of total employment) of Services?
Make the answer very short. -66.2. In the year 1993, what is the difference between the Employment (as % of total employment) of Agriculture and Employment (as % of total employment) of Self-employed?
Give a very brief answer. -50.9. In the year 1993, what is the difference between the Employment (as % of total employment) of Industry and Employment (as % of total employment) of Services?
Offer a very short reply. -35.9. In the year 1993, what is the difference between the Employment (as % of total employment) in Industry and Employment (as % of total employment) in Self-employed?
Provide a short and direct response. -20.6. In the year 1994, what is the difference between the Employment (as % of total employment) in Agriculture and Employment (as % of total employment) in Industry?
Your answer should be very brief. -30.1. In the year 1994, what is the difference between the Employment (as % of total employment) in Agriculture and Employment (as % of total employment) in Services?
Give a very brief answer. -65.9. In the year 1994, what is the difference between the Employment (as % of total employment) of Agriculture and Employment (as % of total employment) of Self-employed?
Ensure brevity in your answer.  -50.3. In the year 1994, what is the difference between the Employment (as % of total employment) of Industry and Employment (as % of total employment) of Services?
Your answer should be compact. -35.8. In the year 1994, what is the difference between the Employment (as % of total employment) of Industry and Employment (as % of total employment) of Self-employed?
Keep it short and to the point. -20.2. In the year 1994, what is the difference between the Employment (as % of total employment) of Services and Employment (as % of total employment) of Self-employed?
Make the answer very short. 15.6. In the year 1995, what is the difference between the Employment (as % of total employment) in Agriculture and Employment (as % of total employment) in Industry?
Your answer should be compact. -30.5. In the year 1995, what is the difference between the Employment (as % of total employment) of Agriculture and Employment (as % of total employment) of Services?
Offer a terse response. -66.4. In the year 1995, what is the difference between the Employment (as % of total employment) of Agriculture and Employment (as % of total employment) of Self-employed?
Your response must be concise. -48.7. In the year 1995, what is the difference between the Employment (as % of total employment) in Industry and Employment (as % of total employment) in Services?
Your answer should be compact. -35.9. In the year 1995, what is the difference between the Employment (as % of total employment) in Industry and Employment (as % of total employment) in Self-employed?
Your answer should be compact. -18.2. In the year 1996, what is the difference between the Employment (as % of total employment) of Agriculture and Employment (as % of total employment) of Industry?
Give a very brief answer. -28.6. In the year 1996, what is the difference between the Employment (as % of total employment) of Agriculture and Employment (as % of total employment) of Services?
Your answer should be very brief. -67.7. In the year 1996, what is the difference between the Employment (as % of total employment) in Agriculture and Employment (as % of total employment) in Self-employed?
Keep it short and to the point. -49.7. In the year 1996, what is the difference between the Employment (as % of total employment) of Industry and Employment (as % of total employment) of Services?
Your answer should be very brief. -39.1. In the year 1996, what is the difference between the Employment (as % of total employment) in Industry and Employment (as % of total employment) in Self-employed?
Give a very brief answer. -21.1. In the year 1996, what is the difference between the Employment (as % of total employment) in Services and Employment (as % of total employment) in Self-employed?
Ensure brevity in your answer.  18. In the year 1997, what is the difference between the Employment (as % of total employment) in Agriculture and Employment (as % of total employment) in Industry?
Keep it short and to the point. -26.6. In the year 1997, what is the difference between the Employment (as % of total employment) of Agriculture and Employment (as % of total employment) of Services?
Keep it short and to the point. -70.1. In the year 1997, what is the difference between the Employment (as % of total employment) of Agriculture and Employment (as % of total employment) of Self-employed?
Offer a very short reply. -49.7. In the year 1997, what is the difference between the Employment (as % of total employment) of Industry and Employment (as % of total employment) of Services?
Ensure brevity in your answer.  -43.5. In the year 1997, what is the difference between the Employment (as % of total employment) of Industry and Employment (as % of total employment) of Self-employed?
Your answer should be compact. -23.1. In the year 1997, what is the difference between the Employment (as % of total employment) of Services and Employment (as % of total employment) of Self-employed?
Make the answer very short. 20.4. In the year 1998, what is the difference between the Employment (as % of total employment) in Agriculture and Employment (as % of total employment) in Industry?
Offer a terse response. -25.5. In the year 1998, what is the difference between the Employment (as % of total employment) in Agriculture and Employment (as % of total employment) in Services?
Offer a terse response. -71.3. In the year 1998, what is the difference between the Employment (as % of total employment) of Agriculture and Employment (as % of total employment) of Self-employed?
Your answer should be very brief. -48.2. In the year 1998, what is the difference between the Employment (as % of total employment) in Industry and Employment (as % of total employment) in Services?
Your answer should be compact. -45.8. In the year 1998, what is the difference between the Employment (as % of total employment) in Industry and Employment (as % of total employment) in Self-employed?
Your answer should be compact. -22.7. In the year 1998, what is the difference between the Employment (as % of total employment) of Services and Employment (as % of total employment) of Self-employed?
Your answer should be compact. 23.1. What is the ratio of the Employment (as % of total employment) in Industry in 1990 to that in 1991?
Offer a terse response. 1.01. What is the ratio of the Employment (as % of total employment) of Services in 1990 to that in 1991?
Make the answer very short. 1. What is the ratio of the Employment (as % of total employment) in Self-employed in 1990 to that in 1991?
Your answer should be very brief. 0.93. What is the ratio of the Employment (as % of total employment) of Agriculture in 1990 to that in 1992?
Provide a succinct answer. 1. What is the ratio of the Employment (as % of total employment) of Industry in 1990 to that in 1992?
Your response must be concise. 1. What is the ratio of the Employment (as % of total employment) in Services in 1990 to that in 1992?
Provide a succinct answer. 1. What is the ratio of the Employment (as % of total employment) in Self-employed in 1990 to that in 1992?
Your answer should be very brief. 0.75. What is the ratio of the Employment (as % of total employment) of Agriculture in 1990 to that in 1993?
Your answer should be compact. 1.27. What is the ratio of the Employment (as % of total employment) of Industry in 1990 to that in 1993?
Offer a very short reply. 0.98. What is the ratio of the Employment (as % of total employment) in Services in 1990 to that in 1993?
Ensure brevity in your answer.  1.01. What is the ratio of the Employment (as % of total employment) of Self-employed in 1990 to that in 1993?
Your answer should be very brief. 0.69. What is the ratio of the Employment (as % of total employment) of Agriculture in 1990 to that in 1994?
Give a very brief answer. 1.08. What is the ratio of the Employment (as % of total employment) in Industry in 1990 to that in 1994?
Keep it short and to the point. 0.98. What is the ratio of the Employment (as % of total employment) in Services in 1990 to that in 1994?
Your answer should be very brief. 1.01. What is the ratio of the Employment (as % of total employment) in Self-employed in 1990 to that in 1994?
Give a very brief answer. 0.7. What is the ratio of the Employment (as % of total employment) of Agriculture in 1990 to that in 1995?
Keep it short and to the point. 1.4. What is the ratio of the Employment (as % of total employment) of Self-employed in 1990 to that in 1995?
Give a very brief answer. 0.72. What is the ratio of the Employment (as % of total employment) in Industry in 1990 to that in 1996?
Keep it short and to the point. 1.04. What is the ratio of the Employment (as % of total employment) of Services in 1990 to that in 1996?
Provide a short and direct response. 0.98. What is the ratio of the Employment (as % of total employment) of Self-employed in 1990 to that in 1996?
Ensure brevity in your answer.  0.71. What is the ratio of the Employment (as % of total employment) in Industry in 1990 to that in 1997?
Give a very brief answer. 1.12. What is the ratio of the Employment (as % of total employment) in Services in 1990 to that in 1997?
Provide a succinct answer. 0.95. What is the ratio of the Employment (as % of total employment) in Self-employed in 1990 to that in 1997?
Your response must be concise. 0.71. What is the ratio of the Employment (as % of total employment) in Agriculture in 1990 to that in 1998?
Provide a short and direct response. 1.4. What is the ratio of the Employment (as % of total employment) in Industry in 1990 to that in 1998?
Ensure brevity in your answer.  1.17. What is the ratio of the Employment (as % of total employment) of Services in 1990 to that in 1998?
Your response must be concise. 0.94. What is the ratio of the Employment (as % of total employment) of Self-employed in 1990 to that in 1998?
Ensure brevity in your answer.  0.73. What is the ratio of the Employment (as % of total employment) of Agriculture in 1991 to that in 1992?
Make the answer very short. 0.93. What is the ratio of the Employment (as % of total employment) in Industry in 1991 to that in 1992?
Ensure brevity in your answer.  0.99. What is the ratio of the Employment (as % of total employment) of Services in 1991 to that in 1992?
Offer a terse response. 1.01. What is the ratio of the Employment (as % of total employment) in Self-employed in 1991 to that in 1992?
Offer a very short reply. 0.81. What is the ratio of the Employment (as % of total employment) of Agriculture in 1991 to that in 1993?
Ensure brevity in your answer.  1.18. What is the ratio of the Employment (as % of total employment) of Industry in 1991 to that in 1993?
Ensure brevity in your answer.  0.97. What is the ratio of the Employment (as % of total employment) in Services in 1991 to that in 1993?
Your response must be concise. 1.01. What is the ratio of the Employment (as % of total employment) of Self-employed in 1991 to that in 1993?
Provide a short and direct response. 0.74. What is the ratio of the Employment (as % of total employment) of Industry in 1991 to that in 1994?
Your answer should be very brief. 0.97. What is the ratio of the Employment (as % of total employment) of Services in 1991 to that in 1994?
Your response must be concise. 1.01. What is the ratio of the Employment (as % of total employment) of Self-employed in 1991 to that in 1994?
Provide a succinct answer. 0.75. What is the ratio of the Employment (as % of total employment) in Industry in 1991 to that in 1995?
Give a very brief answer. 0.97. What is the ratio of the Employment (as % of total employment) of Services in 1991 to that in 1995?
Your answer should be compact. 1.01. What is the ratio of the Employment (as % of total employment) in Self-employed in 1991 to that in 1995?
Make the answer very short. 0.78. What is the ratio of the Employment (as % of total employment) in Industry in 1991 to that in 1996?
Your response must be concise. 1.03. What is the ratio of the Employment (as % of total employment) of Services in 1991 to that in 1996?
Offer a very short reply. 0.99. What is the ratio of the Employment (as % of total employment) in Self-employed in 1991 to that in 1996?
Give a very brief answer. 0.76. What is the ratio of the Employment (as % of total employment) in Industry in 1991 to that in 1997?
Your response must be concise. 1.11. What is the ratio of the Employment (as % of total employment) of Services in 1991 to that in 1997?
Give a very brief answer. 0.96. What is the ratio of the Employment (as % of total employment) of Self-employed in 1991 to that in 1997?
Ensure brevity in your answer.  0.76. What is the ratio of the Employment (as % of total employment) of Industry in 1991 to that in 1998?
Make the answer very short. 1.15. What is the ratio of the Employment (as % of total employment) of Services in 1991 to that in 1998?
Keep it short and to the point. 0.94. What is the ratio of the Employment (as % of total employment) of Self-employed in 1991 to that in 1998?
Your response must be concise. 0.78. What is the ratio of the Employment (as % of total employment) in Agriculture in 1992 to that in 1993?
Offer a very short reply. 1.27. What is the ratio of the Employment (as % of total employment) in Industry in 1992 to that in 1993?
Offer a terse response. 0.98. What is the ratio of the Employment (as % of total employment) in Self-employed in 1992 to that in 1993?
Provide a succinct answer. 0.92. What is the ratio of the Employment (as % of total employment) in Agriculture in 1992 to that in 1994?
Your answer should be compact. 1.08. What is the ratio of the Employment (as % of total employment) of Industry in 1992 to that in 1994?
Offer a terse response. 0.98. What is the ratio of the Employment (as % of total employment) in Self-employed in 1992 to that in 1994?
Ensure brevity in your answer.  0.93. What is the ratio of the Employment (as % of total employment) of Self-employed in 1992 to that in 1995?
Offer a very short reply. 0.96. What is the ratio of the Employment (as % of total employment) in Agriculture in 1992 to that in 1996?
Keep it short and to the point. 1.17. What is the ratio of the Employment (as % of total employment) in Industry in 1992 to that in 1996?
Offer a very short reply. 1.04. What is the ratio of the Employment (as % of total employment) in Services in 1992 to that in 1996?
Offer a very short reply. 0.98. What is the ratio of the Employment (as % of total employment) of Self-employed in 1992 to that in 1996?
Ensure brevity in your answer.  0.94. What is the ratio of the Employment (as % of total employment) in Industry in 1992 to that in 1997?
Keep it short and to the point. 1.12. What is the ratio of the Employment (as % of total employment) in Services in 1992 to that in 1997?
Your response must be concise. 0.95. What is the ratio of the Employment (as % of total employment) of Self-employed in 1992 to that in 1997?
Your answer should be very brief. 0.94. What is the ratio of the Employment (as % of total employment) of Industry in 1992 to that in 1998?
Offer a terse response. 1.17. What is the ratio of the Employment (as % of total employment) of Services in 1992 to that in 1998?
Your response must be concise. 0.93. What is the ratio of the Employment (as % of total employment) in Self-employed in 1992 to that in 1998?
Your response must be concise. 0.97. What is the ratio of the Employment (as % of total employment) in Agriculture in 1993 to that in 1994?
Provide a short and direct response. 0.85. What is the ratio of the Employment (as % of total employment) in Services in 1993 to that in 1994?
Give a very brief answer. 1. What is the ratio of the Employment (as % of total employment) of Agriculture in 1993 to that in 1995?
Provide a succinct answer. 1.1. What is the ratio of the Employment (as % of total employment) of Industry in 1993 to that in 1995?
Your answer should be very brief. 1. What is the ratio of the Employment (as % of total employment) of Self-employed in 1993 to that in 1995?
Your answer should be very brief. 1.05. What is the ratio of the Employment (as % of total employment) of Industry in 1993 to that in 1996?
Your answer should be very brief. 1.05. What is the ratio of the Employment (as % of total employment) in Services in 1993 to that in 1996?
Your answer should be very brief. 0.98. What is the ratio of the Employment (as % of total employment) in Self-employed in 1993 to that in 1996?
Ensure brevity in your answer.  1.02. What is the ratio of the Employment (as % of total employment) in Agriculture in 1993 to that in 1997?
Ensure brevity in your answer.  1.1. What is the ratio of the Employment (as % of total employment) in Industry in 1993 to that in 1997?
Offer a very short reply. 1.14. What is the ratio of the Employment (as % of total employment) of Services in 1993 to that in 1997?
Provide a short and direct response. 0.95. What is the ratio of the Employment (as % of total employment) of Self-employed in 1993 to that in 1997?
Provide a succinct answer. 1.03. What is the ratio of the Employment (as % of total employment) in Agriculture in 1993 to that in 1998?
Keep it short and to the point. 1.1. What is the ratio of the Employment (as % of total employment) of Industry in 1993 to that in 1998?
Provide a short and direct response. 1.18. What is the ratio of the Employment (as % of total employment) of Services in 1993 to that in 1998?
Your answer should be compact. 0.93. What is the ratio of the Employment (as % of total employment) of Self-employed in 1993 to that in 1998?
Provide a succinct answer. 1.06. What is the ratio of the Employment (as % of total employment) of Agriculture in 1994 to that in 1995?
Ensure brevity in your answer.  1.3. What is the ratio of the Employment (as % of total employment) of Self-employed in 1994 to that in 1995?
Provide a succinct answer. 1.04. What is the ratio of the Employment (as % of total employment) of Industry in 1994 to that in 1996?
Your answer should be very brief. 1.05. What is the ratio of the Employment (as % of total employment) of Services in 1994 to that in 1996?
Keep it short and to the point. 0.98. What is the ratio of the Employment (as % of total employment) in Self-employed in 1994 to that in 1996?
Ensure brevity in your answer.  1.01. What is the ratio of the Employment (as % of total employment) in Industry in 1994 to that in 1997?
Your answer should be compact. 1.14. What is the ratio of the Employment (as % of total employment) of Services in 1994 to that in 1997?
Your answer should be very brief. 0.95. What is the ratio of the Employment (as % of total employment) of Self-employed in 1994 to that in 1997?
Provide a succinct answer. 1.02. What is the ratio of the Employment (as % of total employment) in Agriculture in 1994 to that in 1998?
Keep it short and to the point. 1.3. What is the ratio of the Employment (as % of total employment) in Industry in 1994 to that in 1998?
Keep it short and to the point. 1.18. What is the ratio of the Employment (as % of total employment) of Services in 1994 to that in 1998?
Keep it short and to the point. 0.93. What is the ratio of the Employment (as % of total employment) of Self-employed in 1994 to that in 1998?
Your answer should be compact. 1.05. What is the ratio of the Employment (as % of total employment) of Agriculture in 1995 to that in 1996?
Offer a very short reply. 0.83. What is the ratio of the Employment (as % of total employment) in Industry in 1995 to that in 1996?
Keep it short and to the point. 1.06. What is the ratio of the Employment (as % of total employment) in Services in 1995 to that in 1996?
Give a very brief answer. 0.98. What is the ratio of the Employment (as % of total employment) of Self-employed in 1995 to that in 1996?
Make the answer very short. 0.98. What is the ratio of the Employment (as % of total employment) in Agriculture in 1995 to that in 1997?
Provide a short and direct response. 1. What is the ratio of the Employment (as % of total employment) of Industry in 1995 to that in 1997?
Make the answer very short. 1.14. What is the ratio of the Employment (as % of total employment) in Services in 1995 to that in 1997?
Provide a short and direct response. 0.95. What is the ratio of the Employment (as % of total employment) of Self-employed in 1995 to that in 1997?
Ensure brevity in your answer.  0.98. What is the ratio of the Employment (as % of total employment) in Industry in 1995 to that in 1998?
Your answer should be very brief. 1.19. What is the ratio of the Employment (as % of total employment) of Services in 1995 to that in 1998?
Ensure brevity in your answer.  0.93. What is the ratio of the Employment (as % of total employment) in Self-employed in 1995 to that in 1998?
Your answer should be compact. 1.01. What is the ratio of the Employment (as % of total employment) in Agriculture in 1996 to that in 1997?
Give a very brief answer. 1.2. What is the ratio of the Employment (as % of total employment) of Industry in 1996 to that in 1997?
Offer a very short reply. 1.08. What is the ratio of the Employment (as % of total employment) in Services in 1996 to that in 1997?
Make the answer very short. 0.97. What is the ratio of the Employment (as % of total employment) of Agriculture in 1996 to that in 1998?
Your answer should be very brief. 1.2. What is the ratio of the Employment (as % of total employment) of Industry in 1996 to that in 1998?
Your response must be concise. 1.12. What is the ratio of the Employment (as % of total employment) in Services in 1996 to that in 1998?
Offer a terse response. 0.95. What is the ratio of the Employment (as % of total employment) in Self-employed in 1996 to that in 1998?
Ensure brevity in your answer.  1.03. What is the ratio of the Employment (as % of total employment) of Industry in 1997 to that in 1998?
Offer a terse response. 1.04. What is the ratio of the Employment (as % of total employment) of Services in 1997 to that in 1998?
Ensure brevity in your answer.  0.98. What is the ratio of the Employment (as % of total employment) in Self-employed in 1997 to that in 1998?
Keep it short and to the point. 1.03. What is the difference between the highest and the second highest Employment (as % of total employment) of Services?
Give a very brief answer. 1.2. What is the difference between the highest and the second highest Employment (as % of total employment) in Self-employed?
Offer a terse response. 0.4. What is the difference between the highest and the lowest Employment (as % of total employment) of Industry?
Make the answer very short. 5. 